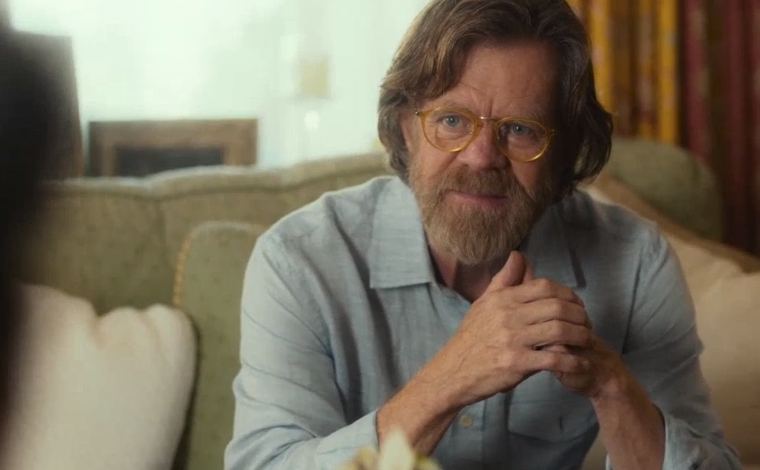Describe the setting around the man. How does it contribute to the mood of the photograph? The setting appears to be a room with soft, natural lighting which creates a serene and intimate atmosphere. The neutral colors and blurred background focus our attention on the man, enhancing the reflective mood of the image. The environment suggests a calm, private space, likely a home, which supports the personal and introspective nature of the moment being captured. 